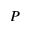Convert formula to latex. <formula><loc_0><loc_0><loc_500><loc_500>P</formula> 